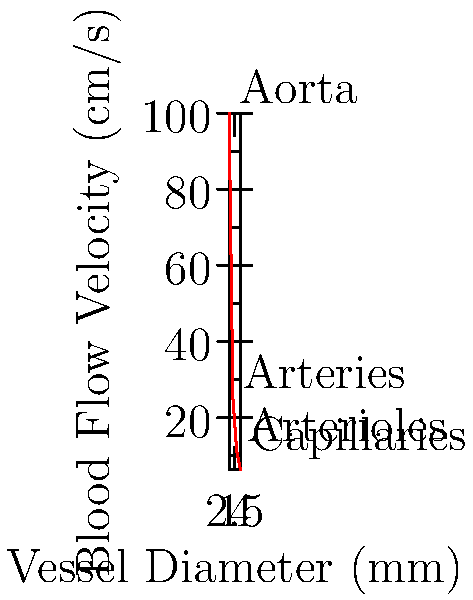The graph shows the relationship between blood vessel diameter and blood flow velocity in different parts of the circulatory system. If the cross-sectional area of a blood vessel is inversely proportional to the blood flow velocity, and the blood flow rate (volume per unit time) remains constant throughout the system, what is the ratio of the total cross-sectional area of all capillaries to the cross-sectional area of the aorta? Let's approach this step-by-step:

1) First, recall the continuity equation for fluid flow: $Q = Av$, where $Q$ is the flow rate, $A$ is the cross-sectional area, and $v$ is the velocity.

2) We're told that the flow rate $Q$ is constant throughout the system. Let's call the values for the aorta $A_1$ and $v_1$, and for capillaries $A_2$ and $v_2$.

3) So we have: $Q = A_1v_1 = A_2v_2$

4) From the graph, we can read:
   $v_1$ (aorta) = 100 cm/s
   $v_2$ (capillaries) = 6.25 cm/s

5) Substituting these into our equation:
   $A_1(100) = A_2(6.25)$

6) Rearranging to find the ratio $A_2/A_1$:
   $A_2/A_1 = 100/6.25 = 16$

Therefore, the total cross-sectional area of all capillaries is 16 times the cross-sectional area of the aorta.
Answer: 16:1 